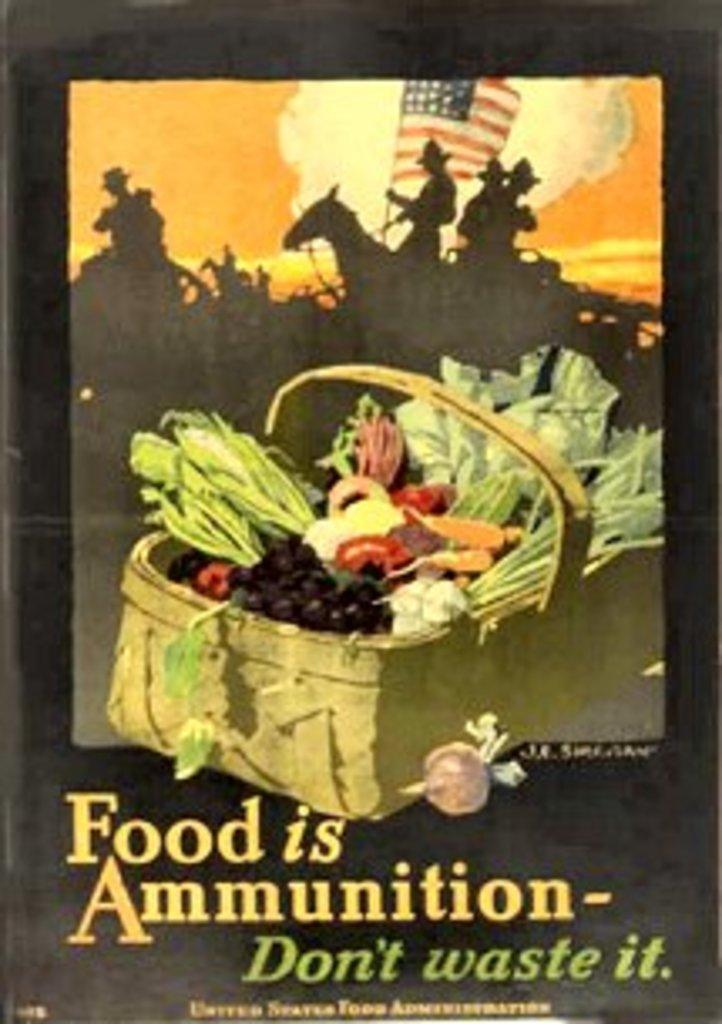<image>
Summarize the visual content of the image. Poster that shows a basket of fruits with soldiers in the background and the words " Food is Ammunition". 